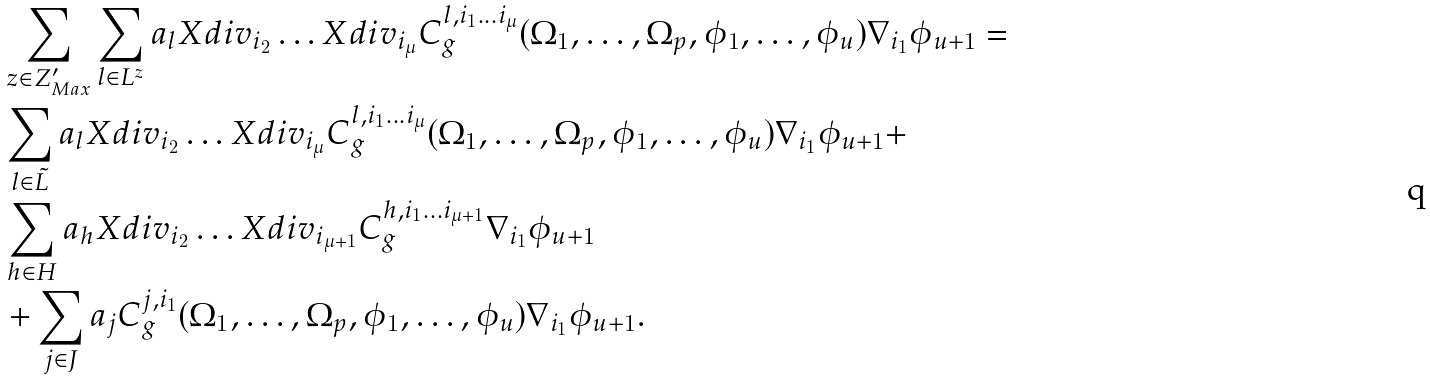<formula> <loc_0><loc_0><loc_500><loc_500>& \sum _ { z \in Z ^ { \prime } _ { M a x } } \sum _ { l \in L ^ { z } } a _ { l } X d i v _ { i _ { 2 } } \dots X d i v _ { i _ { \mu } } C ^ { l , i _ { 1 } \dots i _ { \mu } } _ { g } ( \Omega _ { 1 } , \dots , \Omega _ { p } , \phi _ { 1 } , \dots , \phi _ { u } ) \nabla _ { i _ { 1 } } \phi _ { u + 1 } = \\ & \sum _ { l \in \tilde { L } } a _ { l } X d i v _ { i _ { 2 } } \dots X d i v _ { i _ { \mu } } C ^ { l , i _ { 1 } \dots i _ { \mu } } _ { g } ( \Omega _ { 1 } , \dots , \Omega _ { p } , \phi _ { 1 } , \dots , \phi _ { u } ) \nabla _ { i _ { 1 } } \phi _ { u + 1 } + \\ & \sum _ { h \in H } a _ { h } X d i v _ { i _ { 2 } } \dots X d i v _ { i _ { \mu + 1 } } C ^ { h , i _ { 1 } \dots i _ { \mu + 1 } } _ { g } \nabla _ { i _ { 1 } } \phi _ { u + 1 } \\ & + \sum _ { j \in J } a _ { j } C ^ { j , i _ { 1 } } _ { g } ( \Omega _ { 1 } , \dots , \Omega _ { p } , \phi _ { 1 } , \dots , \phi _ { u } ) \nabla _ { i _ { 1 } } \phi _ { u + 1 } .</formula> 